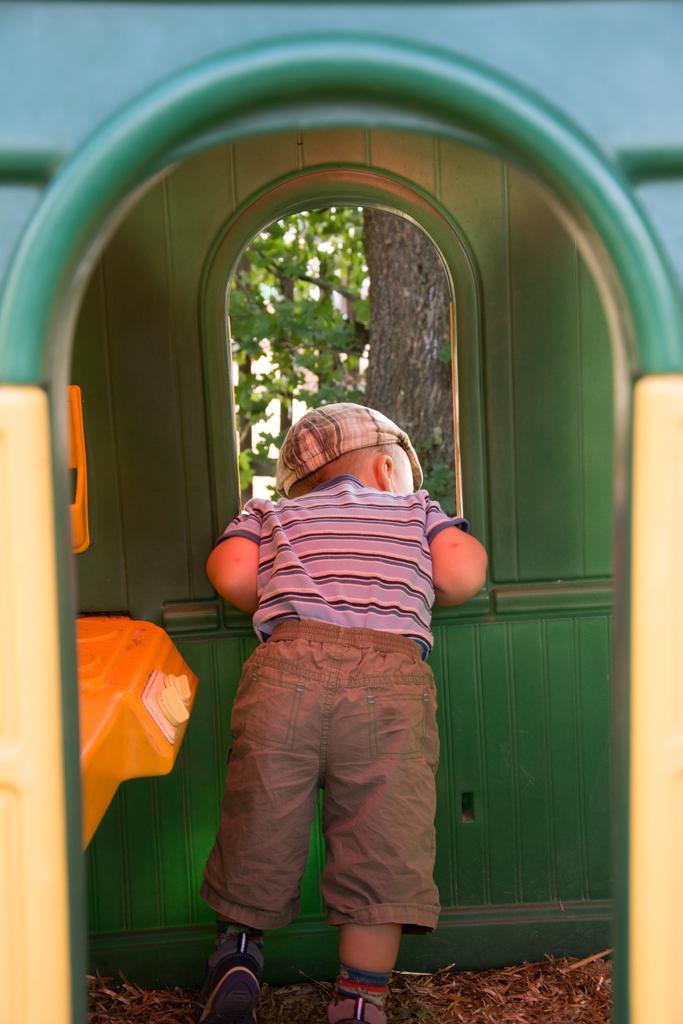Please provide a concise description of this image. In this image there is a small boy inside the room also there is a view of trees from the window. 